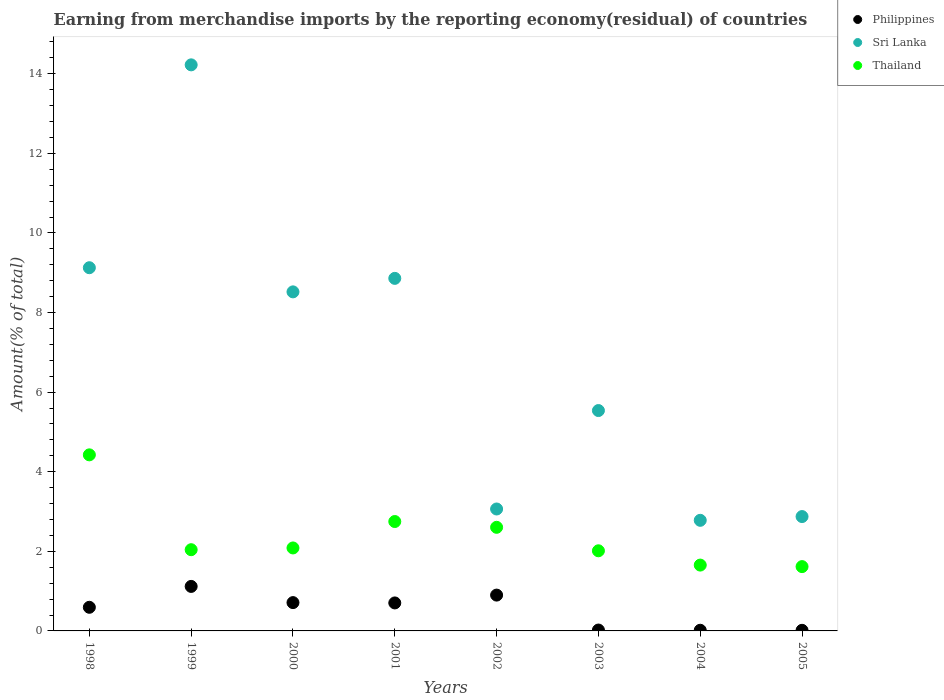How many different coloured dotlines are there?
Provide a short and direct response. 3. What is the percentage of amount earned from merchandise imports in Sri Lanka in 2004?
Your response must be concise. 2.78. Across all years, what is the maximum percentage of amount earned from merchandise imports in Thailand?
Your answer should be very brief. 4.42. Across all years, what is the minimum percentage of amount earned from merchandise imports in Thailand?
Offer a very short reply. 1.62. In which year was the percentage of amount earned from merchandise imports in Sri Lanka maximum?
Offer a very short reply. 1999. What is the total percentage of amount earned from merchandise imports in Philippines in the graph?
Offer a very short reply. 4.08. What is the difference between the percentage of amount earned from merchandise imports in Philippines in 1998 and that in 2001?
Your answer should be very brief. -0.11. What is the difference between the percentage of amount earned from merchandise imports in Sri Lanka in 1998 and the percentage of amount earned from merchandise imports in Philippines in 2005?
Your answer should be compact. 9.11. What is the average percentage of amount earned from merchandise imports in Thailand per year?
Offer a terse response. 2.4. In the year 1998, what is the difference between the percentage of amount earned from merchandise imports in Sri Lanka and percentage of amount earned from merchandise imports in Philippines?
Offer a very short reply. 8.53. In how many years, is the percentage of amount earned from merchandise imports in Thailand greater than 3.6 %?
Provide a succinct answer. 1. What is the ratio of the percentage of amount earned from merchandise imports in Sri Lanka in 1998 to that in 2000?
Your response must be concise. 1.07. What is the difference between the highest and the second highest percentage of amount earned from merchandise imports in Thailand?
Give a very brief answer. 1.68. What is the difference between the highest and the lowest percentage of amount earned from merchandise imports in Thailand?
Provide a succinct answer. 2.81. Is the sum of the percentage of amount earned from merchandise imports in Thailand in 1998 and 2000 greater than the maximum percentage of amount earned from merchandise imports in Philippines across all years?
Ensure brevity in your answer.  Yes. Is it the case that in every year, the sum of the percentage of amount earned from merchandise imports in Sri Lanka and percentage of amount earned from merchandise imports in Philippines  is greater than the percentage of amount earned from merchandise imports in Thailand?
Your response must be concise. Yes. Does the graph contain grids?
Give a very brief answer. No. Where does the legend appear in the graph?
Provide a short and direct response. Top right. How are the legend labels stacked?
Your answer should be compact. Vertical. What is the title of the graph?
Make the answer very short. Earning from merchandise imports by the reporting economy(residual) of countries. Does "Slovenia" appear as one of the legend labels in the graph?
Ensure brevity in your answer.  No. What is the label or title of the X-axis?
Keep it short and to the point. Years. What is the label or title of the Y-axis?
Your answer should be very brief. Amount(% of total). What is the Amount(% of total) in Philippines in 1998?
Your response must be concise. 0.59. What is the Amount(% of total) in Sri Lanka in 1998?
Your response must be concise. 9.13. What is the Amount(% of total) of Thailand in 1998?
Offer a very short reply. 4.42. What is the Amount(% of total) of Philippines in 1999?
Provide a succinct answer. 1.12. What is the Amount(% of total) of Sri Lanka in 1999?
Offer a very short reply. 14.23. What is the Amount(% of total) in Thailand in 1999?
Offer a terse response. 2.04. What is the Amount(% of total) in Philippines in 2000?
Provide a short and direct response. 0.71. What is the Amount(% of total) in Sri Lanka in 2000?
Provide a succinct answer. 8.52. What is the Amount(% of total) of Thailand in 2000?
Make the answer very short. 2.09. What is the Amount(% of total) of Philippines in 2001?
Your response must be concise. 0.7. What is the Amount(% of total) in Sri Lanka in 2001?
Provide a short and direct response. 8.86. What is the Amount(% of total) of Thailand in 2001?
Your answer should be compact. 2.75. What is the Amount(% of total) of Philippines in 2002?
Offer a terse response. 0.9. What is the Amount(% of total) of Sri Lanka in 2002?
Give a very brief answer. 3.06. What is the Amount(% of total) of Thailand in 2002?
Your answer should be very brief. 2.6. What is the Amount(% of total) in Philippines in 2003?
Provide a succinct answer. 0.02. What is the Amount(% of total) of Sri Lanka in 2003?
Ensure brevity in your answer.  5.54. What is the Amount(% of total) in Thailand in 2003?
Keep it short and to the point. 2.01. What is the Amount(% of total) of Philippines in 2004?
Make the answer very short. 0.02. What is the Amount(% of total) in Sri Lanka in 2004?
Offer a terse response. 2.78. What is the Amount(% of total) in Thailand in 2004?
Your answer should be compact. 1.65. What is the Amount(% of total) in Philippines in 2005?
Your answer should be very brief. 0.02. What is the Amount(% of total) of Sri Lanka in 2005?
Offer a terse response. 2.87. What is the Amount(% of total) of Thailand in 2005?
Your response must be concise. 1.62. Across all years, what is the maximum Amount(% of total) of Philippines?
Keep it short and to the point. 1.12. Across all years, what is the maximum Amount(% of total) in Sri Lanka?
Your answer should be very brief. 14.23. Across all years, what is the maximum Amount(% of total) in Thailand?
Keep it short and to the point. 4.42. Across all years, what is the minimum Amount(% of total) of Philippines?
Offer a very short reply. 0.02. Across all years, what is the minimum Amount(% of total) of Sri Lanka?
Make the answer very short. 2.78. Across all years, what is the minimum Amount(% of total) in Thailand?
Offer a very short reply. 1.62. What is the total Amount(% of total) in Philippines in the graph?
Provide a short and direct response. 4.08. What is the total Amount(% of total) of Sri Lanka in the graph?
Your response must be concise. 54.99. What is the total Amount(% of total) of Thailand in the graph?
Make the answer very short. 19.19. What is the difference between the Amount(% of total) of Philippines in 1998 and that in 1999?
Give a very brief answer. -0.52. What is the difference between the Amount(% of total) in Sri Lanka in 1998 and that in 1999?
Make the answer very short. -5.1. What is the difference between the Amount(% of total) in Thailand in 1998 and that in 1999?
Your response must be concise. 2.38. What is the difference between the Amount(% of total) of Philippines in 1998 and that in 2000?
Keep it short and to the point. -0.12. What is the difference between the Amount(% of total) of Sri Lanka in 1998 and that in 2000?
Provide a succinct answer. 0.61. What is the difference between the Amount(% of total) of Thailand in 1998 and that in 2000?
Keep it short and to the point. 2.34. What is the difference between the Amount(% of total) of Philippines in 1998 and that in 2001?
Your answer should be very brief. -0.11. What is the difference between the Amount(% of total) in Sri Lanka in 1998 and that in 2001?
Your answer should be very brief. 0.27. What is the difference between the Amount(% of total) in Thailand in 1998 and that in 2001?
Provide a short and direct response. 1.68. What is the difference between the Amount(% of total) in Philippines in 1998 and that in 2002?
Offer a terse response. -0.31. What is the difference between the Amount(% of total) in Sri Lanka in 1998 and that in 2002?
Keep it short and to the point. 6.06. What is the difference between the Amount(% of total) of Thailand in 1998 and that in 2002?
Your answer should be very brief. 1.82. What is the difference between the Amount(% of total) of Philippines in 1998 and that in 2003?
Make the answer very short. 0.57. What is the difference between the Amount(% of total) of Sri Lanka in 1998 and that in 2003?
Give a very brief answer. 3.59. What is the difference between the Amount(% of total) of Thailand in 1998 and that in 2003?
Make the answer very short. 2.41. What is the difference between the Amount(% of total) of Philippines in 1998 and that in 2004?
Your answer should be compact. 0.58. What is the difference between the Amount(% of total) of Sri Lanka in 1998 and that in 2004?
Give a very brief answer. 6.35. What is the difference between the Amount(% of total) of Thailand in 1998 and that in 2004?
Keep it short and to the point. 2.77. What is the difference between the Amount(% of total) in Philippines in 1998 and that in 2005?
Offer a very short reply. 0.58. What is the difference between the Amount(% of total) in Sri Lanka in 1998 and that in 2005?
Your answer should be very brief. 6.25. What is the difference between the Amount(% of total) of Thailand in 1998 and that in 2005?
Offer a very short reply. 2.81. What is the difference between the Amount(% of total) in Philippines in 1999 and that in 2000?
Your answer should be very brief. 0.41. What is the difference between the Amount(% of total) in Sri Lanka in 1999 and that in 2000?
Your answer should be compact. 5.71. What is the difference between the Amount(% of total) of Thailand in 1999 and that in 2000?
Offer a terse response. -0.04. What is the difference between the Amount(% of total) in Philippines in 1999 and that in 2001?
Give a very brief answer. 0.41. What is the difference between the Amount(% of total) of Sri Lanka in 1999 and that in 2001?
Ensure brevity in your answer.  5.37. What is the difference between the Amount(% of total) in Thailand in 1999 and that in 2001?
Your answer should be compact. -0.71. What is the difference between the Amount(% of total) of Philippines in 1999 and that in 2002?
Ensure brevity in your answer.  0.22. What is the difference between the Amount(% of total) in Sri Lanka in 1999 and that in 2002?
Provide a short and direct response. 11.16. What is the difference between the Amount(% of total) in Thailand in 1999 and that in 2002?
Your answer should be compact. -0.56. What is the difference between the Amount(% of total) in Philippines in 1999 and that in 2003?
Make the answer very short. 1.1. What is the difference between the Amount(% of total) in Sri Lanka in 1999 and that in 2003?
Keep it short and to the point. 8.69. What is the difference between the Amount(% of total) in Thailand in 1999 and that in 2003?
Your response must be concise. 0.03. What is the difference between the Amount(% of total) in Philippines in 1999 and that in 2004?
Make the answer very short. 1.1. What is the difference between the Amount(% of total) of Sri Lanka in 1999 and that in 2004?
Offer a very short reply. 11.45. What is the difference between the Amount(% of total) of Thailand in 1999 and that in 2004?
Make the answer very short. 0.39. What is the difference between the Amount(% of total) in Philippines in 1999 and that in 2005?
Make the answer very short. 1.1. What is the difference between the Amount(% of total) in Sri Lanka in 1999 and that in 2005?
Keep it short and to the point. 11.35. What is the difference between the Amount(% of total) in Thailand in 1999 and that in 2005?
Ensure brevity in your answer.  0.42. What is the difference between the Amount(% of total) in Philippines in 2000 and that in 2001?
Your answer should be very brief. 0.01. What is the difference between the Amount(% of total) of Sri Lanka in 2000 and that in 2001?
Ensure brevity in your answer.  -0.34. What is the difference between the Amount(% of total) in Thailand in 2000 and that in 2001?
Ensure brevity in your answer.  -0.66. What is the difference between the Amount(% of total) in Philippines in 2000 and that in 2002?
Your response must be concise. -0.19. What is the difference between the Amount(% of total) of Sri Lanka in 2000 and that in 2002?
Give a very brief answer. 5.46. What is the difference between the Amount(% of total) in Thailand in 2000 and that in 2002?
Give a very brief answer. -0.52. What is the difference between the Amount(% of total) in Philippines in 2000 and that in 2003?
Ensure brevity in your answer.  0.69. What is the difference between the Amount(% of total) in Sri Lanka in 2000 and that in 2003?
Provide a short and direct response. 2.98. What is the difference between the Amount(% of total) of Thailand in 2000 and that in 2003?
Provide a succinct answer. 0.07. What is the difference between the Amount(% of total) in Philippines in 2000 and that in 2004?
Give a very brief answer. 0.69. What is the difference between the Amount(% of total) in Sri Lanka in 2000 and that in 2004?
Ensure brevity in your answer.  5.74. What is the difference between the Amount(% of total) of Thailand in 2000 and that in 2004?
Provide a short and direct response. 0.43. What is the difference between the Amount(% of total) of Philippines in 2000 and that in 2005?
Your answer should be compact. 0.7. What is the difference between the Amount(% of total) of Sri Lanka in 2000 and that in 2005?
Keep it short and to the point. 5.65. What is the difference between the Amount(% of total) of Thailand in 2000 and that in 2005?
Give a very brief answer. 0.47. What is the difference between the Amount(% of total) in Philippines in 2001 and that in 2002?
Keep it short and to the point. -0.2. What is the difference between the Amount(% of total) of Sri Lanka in 2001 and that in 2002?
Ensure brevity in your answer.  5.8. What is the difference between the Amount(% of total) in Thailand in 2001 and that in 2002?
Your answer should be compact. 0.15. What is the difference between the Amount(% of total) of Philippines in 2001 and that in 2003?
Your answer should be compact. 0.68. What is the difference between the Amount(% of total) of Sri Lanka in 2001 and that in 2003?
Offer a terse response. 3.32. What is the difference between the Amount(% of total) of Thailand in 2001 and that in 2003?
Make the answer very short. 0.74. What is the difference between the Amount(% of total) in Philippines in 2001 and that in 2004?
Provide a short and direct response. 0.69. What is the difference between the Amount(% of total) of Sri Lanka in 2001 and that in 2004?
Offer a very short reply. 6.08. What is the difference between the Amount(% of total) of Thailand in 2001 and that in 2004?
Your answer should be very brief. 1.09. What is the difference between the Amount(% of total) in Philippines in 2001 and that in 2005?
Offer a terse response. 0.69. What is the difference between the Amount(% of total) of Sri Lanka in 2001 and that in 2005?
Make the answer very short. 5.99. What is the difference between the Amount(% of total) in Thailand in 2001 and that in 2005?
Your response must be concise. 1.13. What is the difference between the Amount(% of total) of Philippines in 2002 and that in 2003?
Provide a succinct answer. 0.88. What is the difference between the Amount(% of total) in Sri Lanka in 2002 and that in 2003?
Your answer should be compact. -2.47. What is the difference between the Amount(% of total) of Thailand in 2002 and that in 2003?
Your response must be concise. 0.59. What is the difference between the Amount(% of total) of Philippines in 2002 and that in 2004?
Your answer should be compact. 0.88. What is the difference between the Amount(% of total) in Sri Lanka in 2002 and that in 2004?
Make the answer very short. 0.28. What is the difference between the Amount(% of total) of Thailand in 2002 and that in 2004?
Offer a terse response. 0.95. What is the difference between the Amount(% of total) in Philippines in 2002 and that in 2005?
Give a very brief answer. 0.88. What is the difference between the Amount(% of total) of Sri Lanka in 2002 and that in 2005?
Your response must be concise. 0.19. What is the difference between the Amount(% of total) in Thailand in 2002 and that in 2005?
Make the answer very short. 0.99. What is the difference between the Amount(% of total) in Philippines in 2003 and that in 2004?
Give a very brief answer. 0.01. What is the difference between the Amount(% of total) of Sri Lanka in 2003 and that in 2004?
Make the answer very short. 2.76. What is the difference between the Amount(% of total) of Thailand in 2003 and that in 2004?
Make the answer very short. 0.36. What is the difference between the Amount(% of total) in Philippines in 2003 and that in 2005?
Provide a succinct answer. 0.01. What is the difference between the Amount(% of total) of Sri Lanka in 2003 and that in 2005?
Provide a short and direct response. 2.66. What is the difference between the Amount(% of total) of Thailand in 2003 and that in 2005?
Offer a very short reply. 0.4. What is the difference between the Amount(% of total) of Philippines in 2004 and that in 2005?
Offer a terse response. 0. What is the difference between the Amount(% of total) in Sri Lanka in 2004 and that in 2005?
Keep it short and to the point. -0.09. What is the difference between the Amount(% of total) in Thailand in 2004 and that in 2005?
Offer a very short reply. 0.04. What is the difference between the Amount(% of total) in Philippines in 1998 and the Amount(% of total) in Sri Lanka in 1999?
Provide a succinct answer. -13.63. What is the difference between the Amount(% of total) of Philippines in 1998 and the Amount(% of total) of Thailand in 1999?
Provide a succinct answer. -1.45. What is the difference between the Amount(% of total) of Sri Lanka in 1998 and the Amount(% of total) of Thailand in 1999?
Give a very brief answer. 7.09. What is the difference between the Amount(% of total) in Philippines in 1998 and the Amount(% of total) in Sri Lanka in 2000?
Your response must be concise. -7.93. What is the difference between the Amount(% of total) in Philippines in 1998 and the Amount(% of total) in Thailand in 2000?
Your answer should be compact. -1.49. What is the difference between the Amount(% of total) of Sri Lanka in 1998 and the Amount(% of total) of Thailand in 2000?
Provide a short and direct response. 7.04. What is the difference between the Amount(% of total) of Philippines in 1998 and the Amount(% of total) of Sri Lanka in 2001?
Offer a terse response. -8.27. What is the difference between the Amount(% of total) in Philippines in 1998 and the Amount(% of total) in Thailand in 2001?
Your answer should be compact. -2.16. What is the difference between the Amount(% of total) of Sri Lanka in 1998 and the Amount(% of total) of Thailand in 2001?
Make the answer very short. 6.38. What is the difference between the Amount(% of total) in Philippines in 1998 and the Amount(% of total) in Sri Lanka in 2002?
Give a very brief answer. -2.47. What is the difference between the Amount(% of total) of Philippines in 1998 and the Amount(% of total) of Thailand in 2002?
Provide a succinct answer. -2.01. What is the difference between the Amount(% of total) in Sri Lanka in 1998 and the Amount(% of total) in Thailand in 2002?
Ensure brevity in your answer.  6.52. What is the difference between the Amount(% of total) in Philippines in 1998 and the Amount(% of total) in Sri Lanka in 2003?
Ensure brevity in your answer.  -4.94. What is the difference between the Amount(% of total) in Philippines in 1998 and the Amount(% of total) in Thailand in 2003?
Your answer should be very brief. -1.42. What is the difference between the Amount(% of total) of Sri Lanka in 1998 and the Amount(% of total) of Thailand in 2003?
Make the answer very short. 7.11. What is the difference between the Amount(% of total) in Philippines in 1998 and the Amount(% of total) in Sri Lanka in 2004?
Offer a terse response. -2.19. What is the difference between the Amount(% of total) of Philippines in 1998 and the Amount(% of total) of Thailand in 2004?
Your response must be concise. -1.06. What is the difference between the Amount(% of total) of Sri Lanka in 1998 and the Amount(% of total) of Thailand in 2004?
Ensure brevity in your answer.  7.47. What is the difference between the Amount(% of total) in Philippines in 1998 and the Amount(% of total) in Sri Lanka in 2005?
Provide a succinct answer. -2.28. What is the difference between the Amount(% of total) of Philippines in 1998 and the Amount(% of total) of Thailand in 2005?
Offer a very short reply. -1.02. What is the difference between the Amount(% of total) in Sri Lanka in 1998 and the Amount(% of total) in Thailand in 2005?
Make the answer very short. 7.51. What is the difference between the Amount(% of total) in Philippines in 1999 and the Amount(% of total) in Sri Lanka in 2000?
Your answer should be compact. -7.4. What is the difference between the Amount(% of total) in Philippines in 1999 and the Amount(% of total) in Thailand in 2000?
Give a very brief answer. -0.97. What is the difference between the Amount(% of total) in Sri Lanka in 1999 and the Amount(% of total) in Thailand in 2000?
Your answer should be very brief. 12.14. What is the difference between the Amount(% of total) in Philippines in 1999 and the Amount(% of total) in Sri Lanka in 2001?
Keep it short and to the point. -7.74. What is the difference between the Amount(% of total) in Philippines in 1999 and the Amount(% of total) in Thailand in 2001?
Your answer should be compact. -1.63. What is the difference between the Amount(% of total) in Sri Lanka in 1999 and the Amount(% of total) in Thailand in 2001?
Offer a terse response. 11.48. What is the difference between the Amount(% of total) in Philippines in 1999 and the Amount(% of total) in Sri Lanka in 2002?
Your response must be concise. -1.95. What is the difference between the Amount(% of total) of Philippines in 1999 and the Amount(% of total) of Thailand in 2002?
Give a very brief answer. -1.49. What is the difference between the Amount(% of total) in Sri Lanka in 1999 and the Amount(% of total) in Thailand in 2002?
Keep it short and to the point. 11.62. What is the difference between the Amount(% of total) of Philippines in 1999 and the Amount(% of total) of Sri Lanka in 2003?
Ensure brevity in your answer.  -4.42. What is the difference between the Amount(% of total) of Philippines in 1999 and the Amount(% of total) of Thailand in 2003?
Your answer should be very brief. -0.9. What is the difference between the Amount(% of total) of Sri Lanka in 1999 and the Amount(% of total) of Thailand in 2003?
Offer a very short reply. 12.21. What is the difference between the Amount(% of total) of Philippines in 1999 and the Amount(% of total) of Sri Lanka in 2004?
Your answer should be compact. -1.66. What is the difference between the Amount(% of total) in Philippines in 1999 and the Amount(% of total) in Thailand in 2004?
Offer a very short reply. -0.54. What is the difference between the Amount(% of total) of Sri Lanka in 1999 and the Amount(% of total) of Thailand in 2004?
Your answer should be compact. 12.57. What is the difference between the Amount(% of total) in Philippines in 1999 and the Amount(% of total) in Sri Lanka in 2005?
Provide a short and direct response. -1.76. What is the difference between the Amount(% of total) of Philippines in 1999 and the Amount(% of total) of Thailand in 2005?
Provide a succinct answer. -0.5. What is the difference between the Amount(% of total) of Sri Lanka in 1999 and the Amount(% of total) of Thailand in 2005?
Keep it short and to the point. 12.61. What is the difference between the Amount(% of total) in Philippines in 2000 and the Amount(% of total) in Sri Lanka in 2001?
Offer a very short reply. -8.15. What is the difference between the Amount(% of total) in Philippines in 2000 and the Amount(% of total) in Thailand in 2001?
Your answer should be very brief. -2.04. What is the difference between the Amount(% of total) of Sri Lanka in 2000 and the Amount(% of total) of Thailand in 2001?
Offer a very short reply. 5.77. What is the difference between the Amount(% of total) of Philippines in 2000 and the Amount(% of total) of Sri Lanka in 2002?
Offer a very short reply. -2.35. What is the difference between the Amount(% of total) in Philippines in 2000 and the Amount(% of total) in Thailand in 2002?
Your answer should be very brief. -1.89. What is the difference between the Amount(% of total) in Sri Lanka in 2000 and the Amount(% of total) in Thailand in 2002?
Offer a very short reply. 5.92. What is the difference between the Amount(% of total) in Philippines in 2000 and the Amount(% of total) in Sri Lanka in 2003?
Your answer should be compact. -4.83. What is the difference between the Amount(% of total) in Philippines in 2000 and the Amount(% of total) in Thailand in 2003?
Provide a short and direct response. -1.3. What is the difference between the Amount(% of total) of Sri Lanka in 2000 and the Amount(% of total) of Thailand in 2003?
Your response must be concise. 6.51. What is the difference between the Amount(% of total) of Philippines in 2000 and the Amount(% of total) of Sri Lanka in 2004?
Provide a short and direct response. -2.07. What is the difference between the Amount(% of total) in Philippines in 2000 and the Amount(% of total) in Thailand in 2004?
Provide a succinct answer. -0.94. What is the difference between the Amount(% of total) of Sri Lanka in 2000 and the Amount(% of total) of Thailand in 2004?
Offer a very short reply. 6.87. What is the difference between the Amount(% of total) in Philippines in 2000 and the Amount(% of total) in Sri Lanka in 2005?
Make the answer very short. -2.16. What is the difference between the Amount(% of total) in Philippines in 2000 and the Amount(% of total) in Thailand in 2005?
Your answer should be very brief. -0.9. What is the difference between the Amount(% of total) in Sri Lanka in 2000 and the Amount(% of total) in Thailand in 2005?
Your answer should be very brief. 6.9. What is the difference between the Amount(% of total) in Philippines in 2001 and the Amount(% of total) in Sri Lanka in 2002?
Offer a terse response. -2.36. What is the difference between the Amount(% of total) in Philippines in 2001 and the Amount(% of total) in Thailand in 2002?
Keep it short and to the point. -1.9. What is the difference between the Amount(% of total) in Sri Lanka in 2001 and the Amount(% of total) in Thailand in 2002?
Provide a short and direct response. 6.26. What is the difference between the Amount(% of total) in Philippines in 2001 and the Amount(% of total) in Sri Lanka in 2003?
Your answer should be very brief. -4.83. What is the difference between the Amount(% of total) of Philippines in 2001 and the Amount(% of total) of Thailand in 2003?
Your answer should be very brief. -1.31. What is the difference between the Amount(% of total) in Sri Lanka in 2001 and the Amount(% of total) in Thailand in 2003?
Make the answer very short. 6.85. What is the difference between the Amount(% of total) in Philippines in 2001 and the Amount(% of total) in Sri Lanka in 2004?
Provide a short and direct response. -2.08. What is the difference between the Amount(% of total) of Philippines in 2001 and the Amount(% of total) of Thailand in 2004?
Offer a terse response. -0.95. What is the difference between the Amount(% of total) in Sri Lanka in 2001 and the Amount(% of total) in Thailand in 2004?
Ensure brevity in your answer.  7.21. What is the difference between the Amount(% of total) of Philippines in 2001 and the Amount(% of total) of Sri Lanka in 2005?
Ensure brevity in your answer.  -2.17. What is the difference between the Amount(% of total) in Philippines in 2001 and the Amount(% of total) in Thailand in 2005?
Provide a short and direct response. -0.91. What is the difference between the Amount(% of total) in Sri Lanka in 2001 and the Amount(% of total) in Thailand in 2005?
Your response must be concise. 7.24. What is the difference between the Amount(% of total) in Philippines in 2002 and the Amount(% of total) in Sri Lanka in 2003?
Your answer should be very brief. -4.64. What is the difference between the Amount(% of total) in Philippines in 2002 and the Amount(% of total) in Thailand in 2003?
Your answer should be very brief. -1.11. What is the difference between the Amount(% of total) of Sri Lanka in 2002 and the Amount(% of total) of Thailand in 2003?
Offer a terse response. 1.05. What is the difference between the Amount(% of total) of Philippines in 2002 and the Amount(% of total) of Sri Lanka in 2004?
Provide a short and direct response. -1.88. What is the difference between the Amount(% of total) of Philippines in 2002 and the Amount(% of total) of Thailand in 2004?
Your response must be concise. -0.75. What is the difference between the Amount(% of total) in Sri Lanka in 2002 and the Amount(% of total) in Thailand in 2004?
Your answer should be very brief. 1.41. What is the difference between the Amount(% of total) of Philippines in 2002 and the Amount(% of total) of Sri Lanka in 2005?
Provide a short and direct response. -1.97. What is the difference between the Amount(% of total) of Philippines in 2002 and the Amount(% of total) of Thailand in 2005?
Ensure brevity in your answer.  -0.72. What is the difference between the Amount(% of total) of Sri Lanka in 2002 and the Amount(% of total) of Thailand in 2005?
Keep it short and to the point. 1.45. What is the difference between the Amount(% of total) in Philippines in 2003 and the Amount(% of total) in Sri Lanka in 2004?
Offer a terse response. -2.76. What is the difference between the Amount(% of total) in Philippines in 2003 and the Amount(% of total) in Thailand in 2004?
Offer a very short reply. -1.63. What is the difference between the Amount(% of total) in Sri Lanka in 2003 and the Amount(% of total) in Thailand in 2004?
Provide a succinct answer. 3.88. What is the difference between the Amount(% of total) of Philippines in 2003 and the Amount(% of total) of Sri Lanka in 2005?
Give a very brief answer. -2.85. What is the difference between the Amount(% of total) of Philippines in 2003 and the Amount(% of total) of Thailand in 2005?
Give a very brief answer. -1.59. What is the difference between the Amount(% of total) of Sri Lanka in 2003 and the Amount(% of total) of Thailand in 2005?
Ensure brevity in your answer.  3.92. What is the difference between the Amount(% of total) in Philippines in 2004 and the Amount(% of total) in Sri Lanka in 2005?
Give a very brief answer. -2.86. What is the difference between the Amount(% of total) in Philippines in 2004 and the Amount(% of total) in Thailand in 2005?
Ensure brevity in your answer.  -1.6. What is the difference between the Amount(% of total) of Sri Lanka in 2004 and the Amount(% of total) of Thailand in 2005?
Make the answer very short. 1.16. What is the average Amount(% of total) of Philippines per year?
Offer a very short reply. 0.51. What is the average Amount(% of total) in Sri Lanka per year?
Your answer should be very brief. 6.87. What is the average Amount(% of total) in Thailand per year?
Your answer should be very brief. 2.4. In the year 1998, what is the difference between the Amount(% of total) of Philippines and Amount(% of total) of Sri Lanka?
Offer a very short reply. -8.53. In the year 1998, what is the difference between the Amount(% of total) in Philippines and Amount(% of total) in Thailand?
Provide a succinct answer. -3.83. In the year 1998, what is the difference between the Amount(% of total) in Sri Lanka and Amount(% of total) in Thailand?
Your answer should be very brief. 4.7. In the year 1999, what is the difference between the Amount(% of total) of Philippines and Amount(% of total) of Sri Lanka?
Your response must be concise. -13.11. In the year 1999, what is the difference between the Amount(% of total) of Philippines and Amount(% of total) of Thailand?
Your answer should be compact. -0.92. In the year 1999, what is the difference between the Amount(% of total) of Sri Lanka and Amount(% of total) of Thailand?
Provide a succinct answer. 12.18. In the year 2000, what is the difference between the Amount(% of total) of Philippines and Amount(% of total) of Sri Lanka?
Provide a short and direct response. -7.81. In the year 2000, what is the difference between the Amount(% of total) of Philippines and Amount(% of total) of Thailand?
Make the answer very short. -1.37. In the year 2000, what is the difference between the Amount(% of total) of Sri Lanka and Amount(% of total) of Thailand?
Provide a short and direct response. 6.44. In the year 2001, what is the difference between the Amount(% of total) of Philippines and Amount(% of total) of Sri Lanka?
Make the answer very short. -8.16. In the year 2001, what is the difference between the Amount(% of total) in Philippines and Amount(% of total) in Thailand?
Your response must be concise. -2.05. In the year 2001, what is the difference between the Amount(% of total) in Sri Lanka and Amount(% of total) in Thailand?
Your response must be concise. 6.11. In the year 2002, what is the difference between the Amount(% of total) of Philippines and Amount(% of total) of Sri Lanka?
Give a very brief answer. -2.16. In the year 2002, what is the difference between the Amount(% of total) in Philippines and Amount(% of total) in Thailand?
Your answer should be very brief. -1.7. In the year 2002, what is the difference between the Amount(% of total) in Sri Lanka and Amount(% of total) in Thailand?
Your answer should be very brief. 0.46. In the year 2003, what is the difference between the Amount(% of total) in Philippines and Amount(% of total) in Sri Lanka?
Your answer should be compact. -5.52. In the year 2003, what is the difference between the Amount(% of total) in Philippines and Amount(% of total) in Thailand?
Provide a succinct answer. -1.99. In the year 2003, what is the difference between the Amount(% of total) of Sri Lanka and Amount(% of total) of Thailand?
Make the answer very short. 3.52. In the year 2004, what is the difference between the Amount(% of total) in Philippines and Amount(% of total) in Sri Lanka?
Ensure brevity in your answer.  -2.76. In the year 2004, what is the difference between the Amount(% of total) in Philippines and Amount(% of total) in Thailand?
Give a very brief answer. -1.64. In the year 2004, what is the difference between the Amount(% of total) in Sri Lanka and Amount(% of total) in Thailand?
Your answer should be very brief. 1.13. In the year 2005, what is the difference between the Amount(% of total) in Philippines and Amount(% of total) in Sri Lanka?
Your response must be concise. -2.86. In the year 2005, what is the difference between the Amount(% of total) of Philippines and Amount(% of total) of Thailand?
Your answer should be compact. -1.6. In the year 2005, what is the difference between the Amount(% of total) in Sri Lanka and Amount(% of total) in Thailand?
Your answer should be very brief. 1.26. What is the ratio of the Amount(% of total) in Philippines in 1998 to that in 1999?
Your answer should be very brief. 0.53. What is the ratio of the Amount(% of total) of Sri Lanka in 1998 to that in 1999?
Ensure brevity in your answer.  0.64. What is the ratio of the Amount(% of total) of Thailand in 1998 to that in 1999?
Keep it short and to the point. 2.17. What is the ratio of the Amount(% of total) in Philippines in 1998 to that in 2000?
Keep it short and to the point. 0.83. What is the ratio of the Amount(% of total) of Sri Lanka in 1998 to that in 2000?
Your response must be concise. 1.07. What is the ratio of the Amount(% of total) in Thailand in 1998 to that in 2000?
Give a very brief answer. 2.12. What is the ratio of the Amount(% of total) of Philippines in 1998 to that in 2001?
Your answer should be very brief. 0.84. What is the ratio of the Amount(% of total) in Sri Lanka in 1998 to that in 2001?
Provide a short and direct response. 1.03. What is the ratio of the Amount(% of total) of Thailand in 1998 to that in 2001?
Offer a very short reply. 1.61. What is the ratio of the Amount(% of total) of Philippines in 1998 to that in 2002?
Make the answer very short. 0.66. What is the ratio of the Amount(% of total) of Sri Lanka in 1998 to that in 2002?
Offer a terse response. 2.98. What is the ratio of the Amount(% of total) in Thailand in 1998 to that in 2002?
Offer a terse response. 1.7. What is the ratio of the Amount(% of total) of Philippines in 1998 to that in 2003?
Provide a short and direct response. 26.55. What is the ratio of the Amount(% of total) in Sri Lanka in 1998 to that in 2003?
Ensure brevity in your answer.  1.65. What is the ratio of the Amount(% of total) of Thailand in 1998 to that in 2003?
Your answer should be compact. 2.2. What is the ratio of the Amount(% of total) in Philippines in 1998 to that in 2004?
Offer a very short reply. 35.36. What is the ratio of the Amount(% of total) of Sri Lanka in 1998 to that in 2004?
Offer a very short reply. 3.28. What is the ratio of the Amount(% of total) in Thailand in 1998 to that in 2004?
Give a very brief answer. 2.67. What is the ratio of the Amount(% of total) in Philippines in 1998 to that in 2005?
Your answer should be compact. 38.83. What is the ratio of the Amount(% of total) of Sri Lanka in 1998 to that in 2005?
Offer a terse response. 3.18. What is the ratio of the Amount(% of total) of Thailand in 1998 to that in 2005?
Make the answer very short. 2.74. What is the ratio of the Amount(% of total) of Philippines in 1999 to that in 2000?
Your answer should be very brief. 1.57. What is the ratio of the Amount(% of total) of Sri Lanka in 1999 to that in 2000?
Provide a short and direct response. 1.67. What is the ratio of the Amount(% of total) in Thailand in 1999 to that in 2000?
Offer a terse response. 0.98. What is the ratio of the Amount(% of total) in Philippines in 1999 to that in 2001?
Offer a very short reply. 1.59. What is the ratio of the Amount(% of total) in Sri Lanka in 1999 to that in 2001?
Provide a short and direct response. 1.61. What is the ratio of the Amount(% of total) of Thailand in 1999 to that in 2001?
Give a very brief answer. 0.74. What is the ratio of the Amount(% of total) of Philippines in 1999 to that in 2002?
Your answer should be very brief. 1.24. What is the ratio of the Amount(% of total) in Sri Lanka in 1999 to that in 2002?
Keep it short and to the point. 4.64. What is the ratio of the Amount(% of total) in Thailand in 1999 to that in 2002?
Your answer should be compact. 0.78. What is the ratio of the Amount(% of total) in Philippines in 1999 to that in 2003?
Provide a succinct answer. 50.01. What is the ratio of the Amount(% of total) of Sri Lanka in 1999 to that in 2003?
Offer a very short reply. 2.57. What is the ratio of the Amount(% of total) of Thailand in 1999 to that in 2003?
Offer a very short reply. 1.01. What is the ratio of the Amount(% of total) of Philippines in 1999 to that in 2004?
Your answer should be very brief. 66.62. What is the ratio of the Amount(% of total) of Sri Lanka in 1999 to that in 2004?
Keep it short and to the point. 5.12. What is the ratio of the Amount(% of total) in Thailand in 1999 to that in 2004?
Ensure brevity in your answer.  1.23. What is the ratio of the Amount(% of total) in Philippines in 1999 to that in 2005?
Your response must be concise. 73.14. What is the ratio of the Amount(% of total) of Sri Lanka in 1999 to that in 2005?
Your response must be concise. 4.95. What is the ratio of the Amount(% of total) in Thailand in 1999 to that in 2005?
Make the answer very short. 1.26. What is the ratio of the Amount(% of total) of Philippines in 2000 to that in 2001?
Give a very brief answer. 1.01. What is the ratio of the Amount(% of total) of Sri Lanka in 2000 to that in 2001?
Keep it short and to the point. 0.96. What is the ratio of the Amount(% of total) of Thailand in 2000 to that in 2001?
Provide a short and direct response. 0.76. What is the ratio of the Amount(% of total) of Philippines in 2000 to that in 2002?
Provide a short and direct response. 0.79. What is the ratio of the Amount(% of total) of Sri Lanka in 2000 to that in 2002?
Make the answer very short. 2.78. What is the ratio of the Amount(% of total) in Thailand in 2000 to that in 2002?
Your answer should be very brief. 0.8. What is the ratio of the Amount(% of total) in Philippines in 2000 to that in 2003?
Offer a very short reply. 31.81. What is the ratio of the Amount(% of total) in Sri Lanka in 2000 to that in 2003?
Give a very brief answer. 1.54. What is the ratio of the Amount(% of total) of Thailand in 2000 to that in 2003?
Give a very brief answer. 1.04. What is the ratio of the Amount(% of total) of Philippines in 2000 to that in 2004?
Provide a succinct answer. 42.38. What is the ratio of the Amount(% of total) in Sri Lanka in 2000 to that in 2004?
Make the answer very short. 3.07. What is the ratio of the Amount(% of total) in Thailand in 2000 to that in 2004?
Make the answer very short. 1.26. What is the ratio of the Amount(% of total) in Philippines in 2000 to that in 2005?
Keep it short and to the point. 46.53. What is the ratio of the Amount(% of total) in Sri Lanka in 2000 to that in 2005?
Give a very brief answer. 2.96. What is the ratio of the Amount(% of total) in Thailand in 2000 to that in 2005?
Provide a short and direct response. 1.29. What is the ratio of the Amount(% of total) of Philippines in 2001 to that in 2002?
Keep it short and to the point. 0.78. What is the ratio of the Amount(% of total) in Sri Lanka in 2001 to that in 2002?
Provide a short and direct response. 2.89. What is the ratio of the Amount(% of total) of Thailand in 2001 to that in 2002?
Provide a short and direct response. 1.06. What is the ratio of the Amount(% of total) in Philippines in 2001 to that in 2003?
Make the answer very short. 31.45. What is the ratio of the Amount(% of total) of Sri Lanka in 2001 to that in 2003?
Make the answer very short. 1.6. What is the ratio of the Amount(% of total) in Thailand in 2001 to that in 2003?
Provide a short and direct response. 1.37. What is the ratio of the Amount(% of total) of Philippines in 2001 to that in 2004?
Provide a succinct answer. 41.9. What is the ratio of the Amount(% of total) in Sri Lanka in 2001 to that in 2004?
Provide a succinct answer. 3.19. What is the ratio of the Amount(% of total) of Thailand in 2001 to that in 2004?
Provide a short and direct response. 1.66. What is the ratio of the Amount(% of total) in Philippines in 2001 to that in 2005?
Ensure brevity in your answer.  46. What is the ratio of the Amount(% of total) of Sri Lanka in 2001 to that in 2005?
Offer a terse response. 3.08. What is the ratio of the Amount(% of total) of Thailand in 2001 to that in 2005?
Your answer should be very brief. 1.7. What is the ratio of the Amount(% of total) in Philippines in 2002 to that in 2003?
Make the answer very short. 40.25. What is the ratio of the Amount(% of total) of Sri Lanka in 2002 to that in 2003?
Your answer should be very brief. 0.55. What is the ratio of the Amount(% of total) in Thailand in 2002 to that in 2003?
Give a very brief answer. 1.29. What is the ratio of the Amount(% of total) of Philippines in 2002 to that in 2004?
Provide a short and direct response. 53.62. What is the ratio of the Amount(% of total) in Sri Lanka in 2002 to that in 2004?
Provide a short and direct response. 1.1. What is the ratio of the Amount(% of total) in Thailand in 2002 to that in 2004?
Ensure brevity in your answer.  1.57. What is the ratio of the Amount(% of total) in Philippines in 2002 to that in 2005?
Your response must be concise. 58.87. What is the ratio of the Amount(% of total) of Sri Lanka in 2002 to that in 2005?
Make the answer very short. 1.07. What is the ratio of the Amount(% of total) of Thailand in 2002 to that in 2005?
Offer a very short reply. 1.61. What is the ratio of the Amount(% of total) in Philippines in 2003 to that in 2004?
Offer a terse response. 1.33. What is the ratio of the Amount(% of total) of Sri Lanka in 2003 to that in 2004?
Your answer should be compact. 1.99. What is the ratio of the Amount(% of total) of Thailand in 2003 to that in 2004?
Ensure brevity in your answer.  1.22. What is the ratio of the Amount(% of total) in Philippines in 2003 to that in 2005?
Your answer should be very brief. 1.46. What is the ratio of the Amount(% of total) in Sri Lanka in 2003 to that in 2005?
Keep it short and to the point. 1.93. What is the ratio of the Amount(% of total) of Thailand in 2003 to that in 2005?
Give a very brief answer. 1.25. What is the ratio of the Amount(% of total) in Philippines in 2004 to that in 2005?
Your answer should be compact. 1.1. What is the ratio of the Amount(% of total) of Sri Lanka in 2004 to that in 2005?
Give a very brief answer. 0.97. What is the ratio of the Amount(% of total) of Thailand in 2004 to that in 2005?
Offer a terse response. 1.02. What is the difference between the highest and the second highest Amount(% of total) of Philippines?
Your answer should be very brief. 0.22. What is the difference between the highest and the second highest Amount(% of total) of Sri Lanka?
Provide a short and direct response. 5.1. What is the difference between the highest and the second highest Amount(% of total) of Thailand?
Ensure brevity in your answer.  1.68. What is the difference between the highest and the lowest Amount(% of total) of Philippines?
Keep it short and to the point. 1.1. What is the difference between the highest and the lowest Amount(% of total) of Sri Lanka?
Provide a short and direct response. 11.45. What is the difference between the highest and the lowest Amount(% of total) of Thailand?
Your answer should be compact. 2.81. 